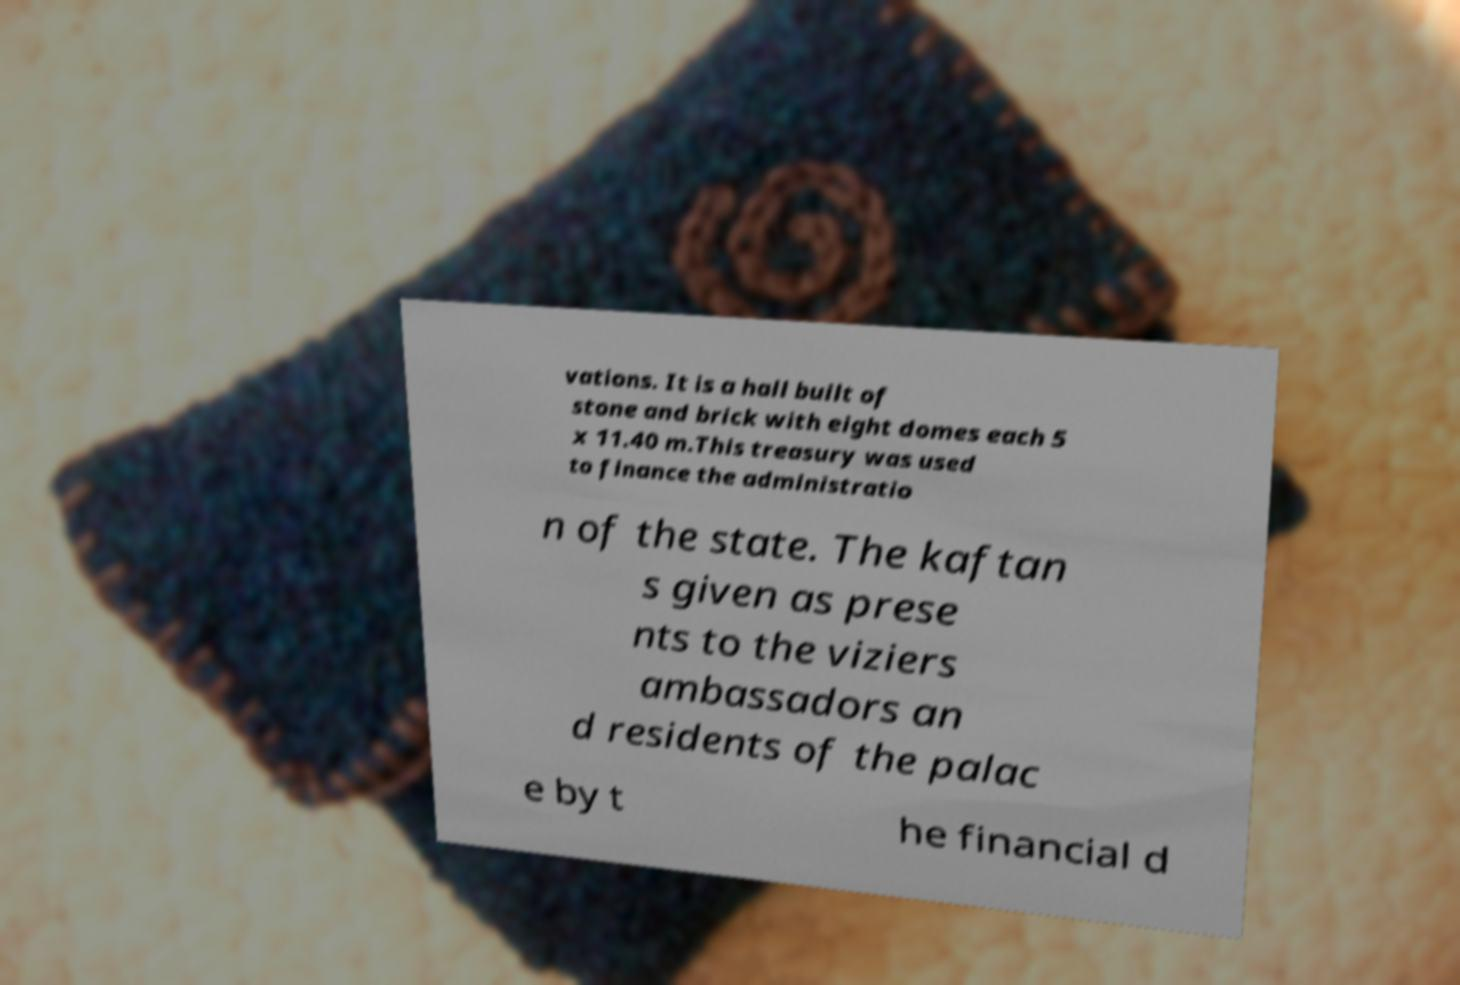Can you accurately transcribe the text from the provided image for me? vations. It is a hall built of stone and brick with eight domes each 5 x 11.40 m.This treasury was used to finance the administratio n of the state. The kaftan s given as prese nts to the viziers ambassadors an d residents of the palac e by t he financial d 